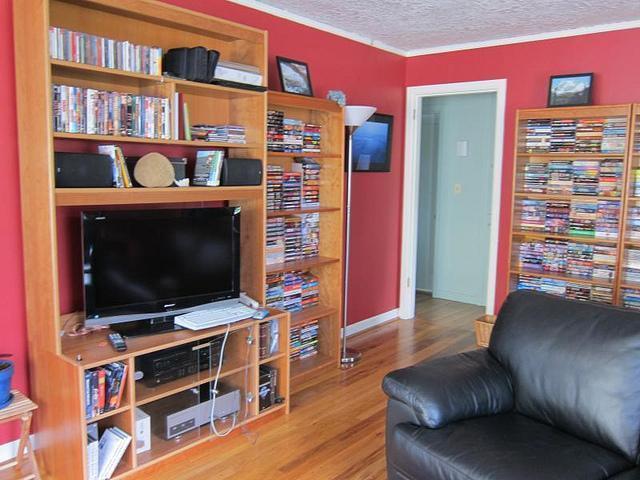How many people are facing the pitcher?
Give a very brief answer. 0. 